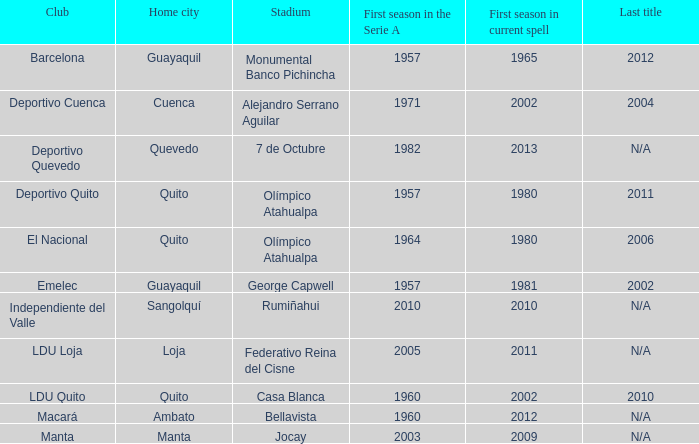Name the last title for 2012 N/A. 